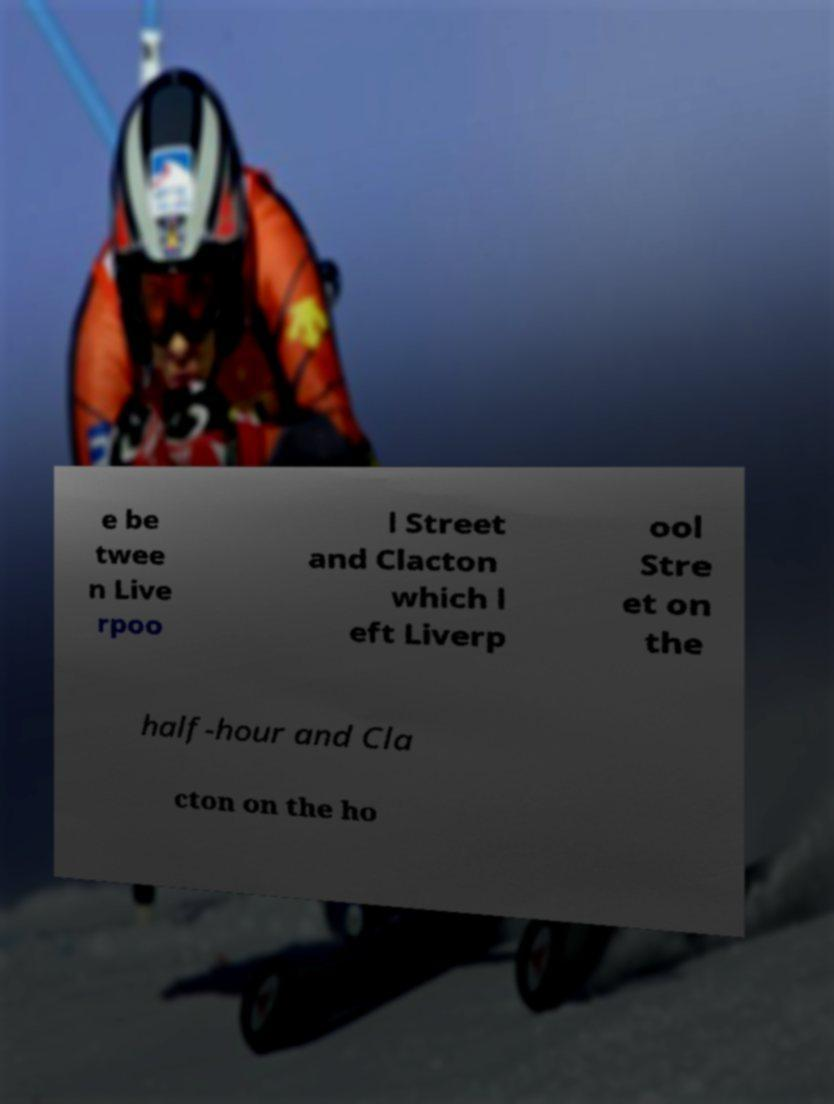For documentation purposes, I need the text within this image transcribed. Could you provide that? e be twee n Live rpoo l Street and Clacton which l eft Liverp ool Stre et on the half-hour and Cla cton on the ho 